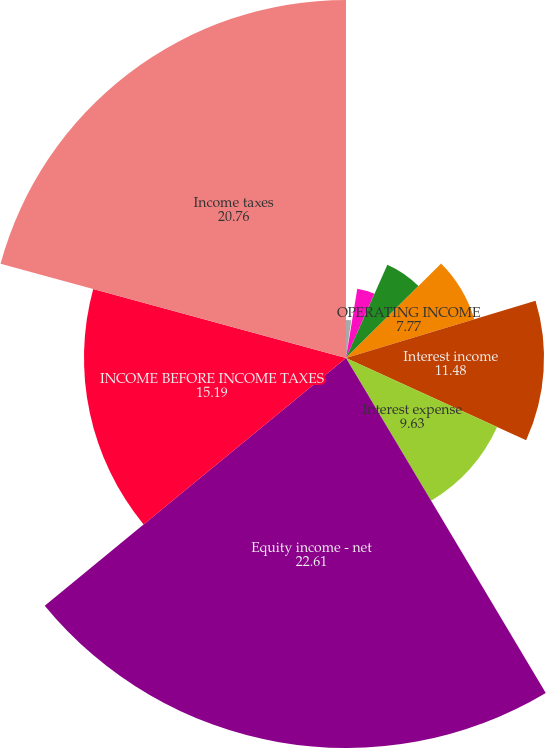<chart> <loc_0><loc_0><loc_500><loc_500><pie_chart><fcel>NET OPERATING REVENUES<fcel>Cost of goods sold<fcel>GROSS PROFIT<fcel>Selling general and<fcel>OPERATING INCOME<fcel>Interest income<fcel>Interest expense<fcel>Equity income - net<fcel>INCOME BEFORE INCOME TAXES<fcel>Income taxes<nl><fcel>2.21%<fcel>0.36%<fcel>4.07%<fcel>5.92%<fcel>7.77%<fcel>11.48%<fcel>9.63%<fcel>22.61%<fcel>15.19%<fcel>20.76%<nl></chart> 